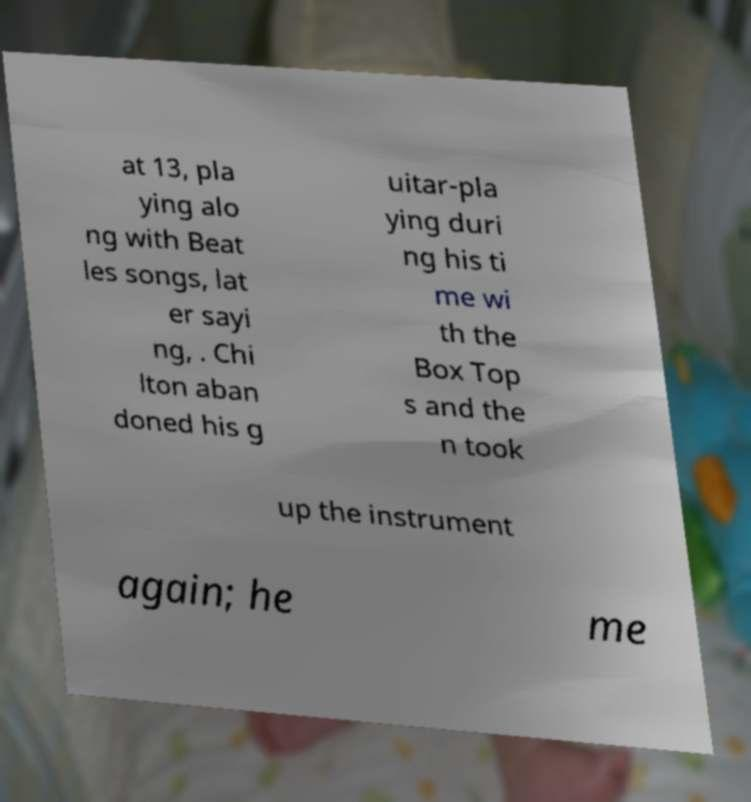I need the written content from this picture converted into text. Can you do that? at 13, pla ying alo ng with Beat les songs, lat er sayi ng, . Chi lton aban doned his g uitar-pla ying duri ng his ti me wi th the Box Top s and the n took up the instrument again; he me 